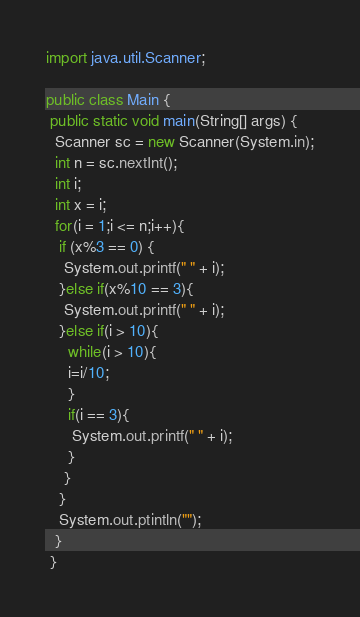Convert code to text. <code><loc_0><loc_0><loc_500><loc_500><_Java_>import java.util.Scanner;

public class Main {
 public static void main(String[] args) {
  Scanner sc = new Scanner(System.in);
  int n = sc.nextInt();
  int i;
  int x = i;
  for(i = 1;i <= n;i++){
   if (x%3 == 0) {
    System.out.printf(" " + i);
   }else if(x%10 == 3){
    System.out.printf(" " + i);
   }else if(i > 10){
     while(i > 10){
     i=i/10;
     }
     if(i == 3){
      System.out.printf(" " + i);
     }
    }
   }
   System.out.ptintln("");
  }
 }</code> 